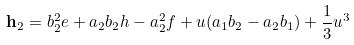Convert formula to latex. <formula><loc_0><loc_0><loc_500><loc_500>{ \mathbf h } _ { 2 } = b _ { 2 } ^ { 2 } e + a _ { 2 } b _ { 2 } h - a _ { 2 } ^ { 2 } f + u ( a _ { 1 } b _ { 2 } - a _ { 2 } b _ { 1 } ) + \frac { 1 } { 3 } u ^ { 3 }</formula> 